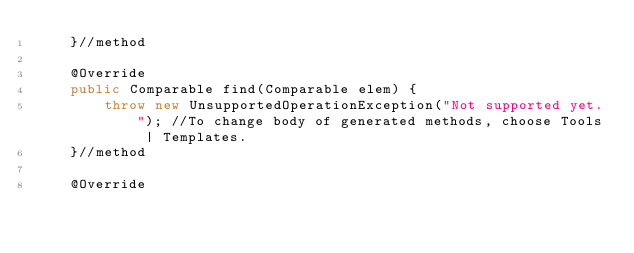<code> <loc_0><loc_0><loc_500><loc_500><_Java_>    }//method

    @Override
    public Comparable find(Comparable elem) {
        throw new UnsupportedOperationException("Not supported yet."); //To change body of generated methods, choose Tools | Templates.
    }//method
    
    @Override</code> 